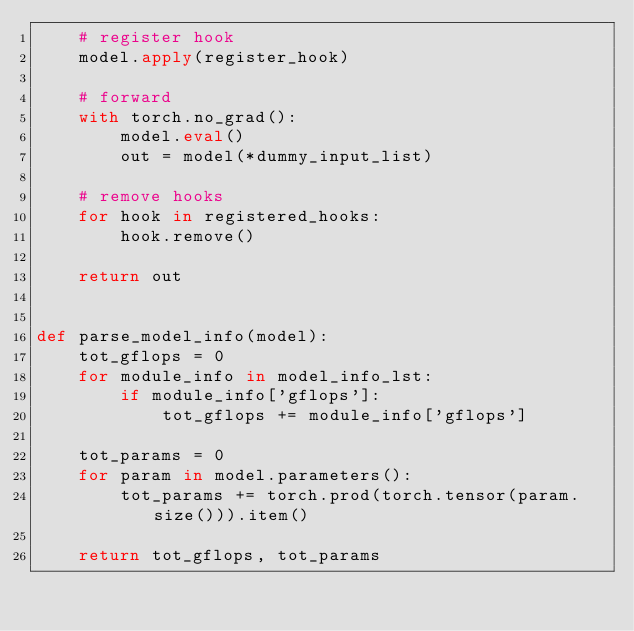Convert code to text. <code><loc_0><loc_0><loc_500><loc_500><_Python_>    # register hook
    model.apply(register_hook)

    # forward
    with torch.no_grad():
        model.eval()
        out = model(*dummy_input_list)

    # remove hooks
    for hook in registered_hooks:
        hook.remove()

    return out


def parse_model_info(model):
    tot_gflops = 0
    for module_info in model_info_lst:
        if module_info['gflops']:
            tot_gflops += module_info['gflops']

    tot_params = 0
    for param in model.parameters():
        tot_params += torch.prod(torch.tensor(param.size())).item()

    return tot_gflops, tot_params
</code> 